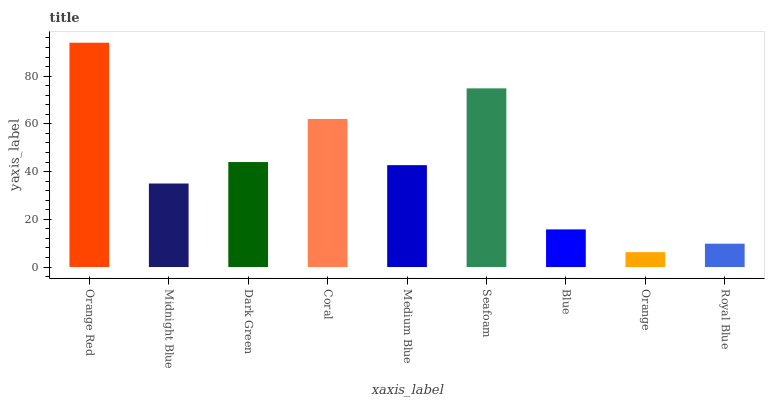Is Orange the minimum?
Answer yes or no. Yes. Is Orange Red the maximum?
Answer yes or no. Yes. Is Midnight Blue the minimum?
Answer yes or no. No. Is Midnight Blue the maximum?
Answer yes or no. No. Is Orange Red greater than Midnight Blue?
Answer yes or no. Yes. Is Midnight Blue less than Orange Red?
Answer yes or no. Yes. Is Midnight Blue greater than Orange Red?
Answer yes or no. No. Is Orange Red less than Midnight Blue?
Answer yes or no. No. Is Medium Blue the high median?
Answer yes or no. Yes. Is Medium Blue the low median?
Answer yes or no. Yes. Is Royal Blue the high median?
Answer yes or no. No. Is Midnight Blue the low median?
Answer yes or no. No. 